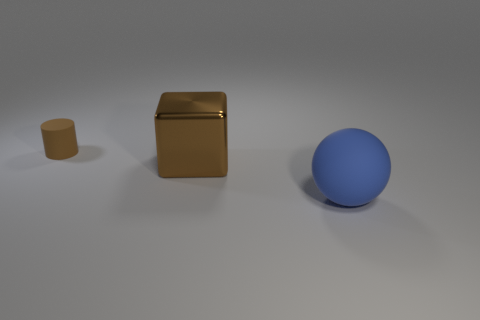Are there any large blocks that have the same color as the small object?
Give a very brief answer. Yes. Are the big cube and the large blue thing made of the same material?
Keep it short and to the point. No. Are there any other things that are made of the same material as the cube?
Make the answer very short. No. Are there fewer rubber things behind the large brown metal cube than small cyan matte cylinders?
Your answer should be very brief. No. There is a brown block; how many big spheres are in front of it?
Offer a very short reply. 1. There is a rubber object that is in front of the tiny rubber cylinder; does it have the same shape as the brown thing in front of the small object?
Your response must be concise. No. What is the shape of the thing that is to the left of the large blue rubber sphere and on the right side of the small matte thing?
Provide a short and direct response. Cube. There is a cylinder that is the same material as the large ball; what size is it?
Your response must be concise. Small. Are there fewer large metallic things than blue rubber cylinders?
Keep it short and to the point. No. What is the material of the thing that is to the left of the large thing that is on the left side of the rubber thing that is on the right side of the small rubber thing?
Keep it short and to the point. Rubber. 